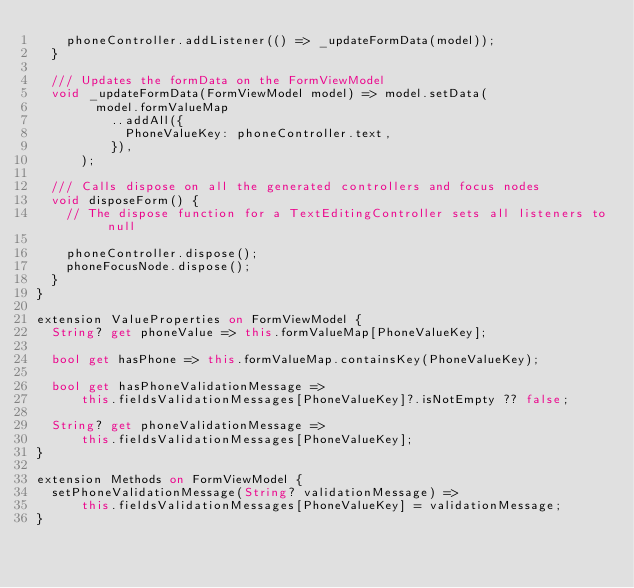Convert code to text. <code><loc_0><loc_0><loc_500><loc_500><_Dart_>    phoneController.addListener(() => _updateFormData(model));
  }

  /// Updates the formData on the FormViewModel
  void _updateFormData(FormViewModel model) => model.setData(
        model.formValueMap
          ..addAll({
            PhoneValueKey: phoneController.text,
          }),
      );

  /// Calls dispose on all the generated controllers and focus nodes
  void disposeForm() {
    // The dispose function for a TextEditingController sets all listeners to null

    phoneController.dispose();
    phoneFocusNode.dispose();
  }
}

extension ValueProperties on FormViewModel {
  String? get phoneValue => this.formValueMap[PhoneValueKey];

  bool get hasPhone => this.formValueMap.containsKey(PhoneValueKey);

  bool get hasPhoneValidationMessage =>
      this.fieldsValidationMessages[PhoneValueKey]?.isNotEmpty ?? false;

  String? get phoneValidationMessage =>
      this.fieldsValidationMessages[PhoneValueKey];
}

extension Methods on FormViewModel {
  setPhoneValidationMessage(String? validationMessage) =>
      this.fieldsValidationMessages[PhoneValueKey] = validationMessage;
}
</code> 